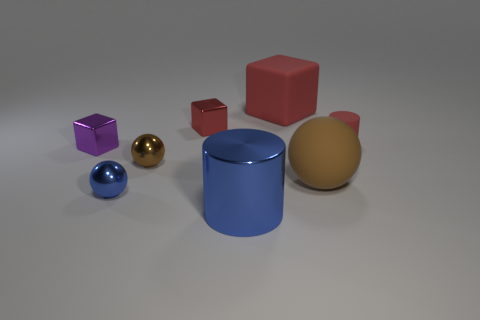What shape is the brown thing that is the same size as the blue metal ball?
Your response must be concise. Sphere. Do the blue sphere that is in front of the small red block and the red object left of the big red matte object have the same material?
Offer a terse response. Yes. The tiny red object that is on the right side of the ball that is to the right of the large blue cylinder is made of what material?
Your answer should be very brief. Rubber. There is a matte object in front of the block on the left side of the brown ball that is left of the brown rubber thing; how big is it?
Provide a succinct answer. Large. Does the purple object have the same size as the rubber cube?
Ensure brevity in your answer.  No. There is a big object behind the red matte cylinder; is it the same shape as the blue metal thing that is in front of the small blue object?
Your answer should be very brief. No. There is a blue metal cylinder that is in front of the small purple cube; are there any small shiny blocks that are right of it?
Keep it short and to the point. No. Are any small brown metallic objects visible?
Offer a very short reply. Yes. How many rubber spheres are the same size as the red metal block?
Offer a very short reply. 0. What number of tiny objects are both to the left of the tiny rubber object and right of the purple shiny thing?
Ensure brevity in your answer.  3. 